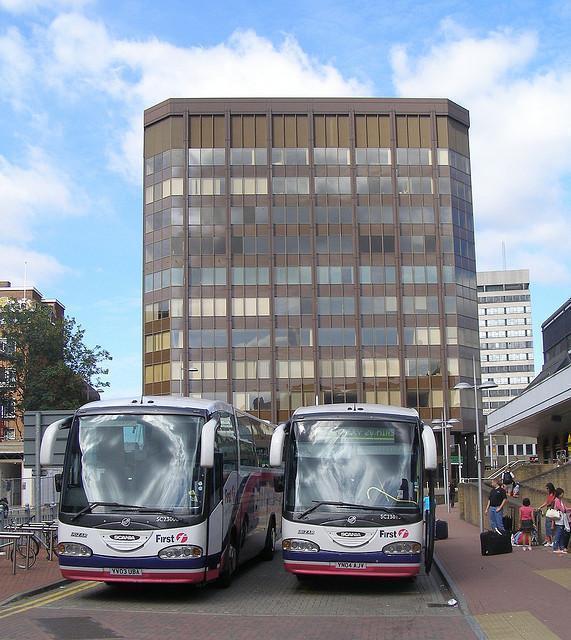What is the black bag on the sidewalk?
Select the accurate response from the four choices given to answer the question.
Options: Tools, luggage, furniture, groceries. Luggage. 